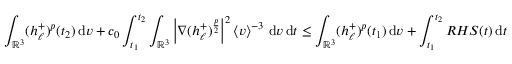Convert formula to latex. <formula><loc_0><loc_0><loc_500><loc_500>\int _ { { \mathbb { R } } ^ { 3 } } ( h _ { \ell } ^ { + } ) ^ { p } ( t _ { 2 } ) \, d v + c _ { 0 } \int _ { t _ { 1 } } ^ { t _ { 2 } } \int _ { { \mathbb { R } } ^ { 3 } } \left | \nabla ( h _ { \ell } ^ { + } ) ^ { \frac { p } { 2 } } \right | ^ { 2 } \left \langle v \right \rangle ^ { - 3 } \, d v \, d t \leq \int _ { { \mathbb { R } } ^ { 3 } } ( h _ { \ell } ^ { + } ) ^ { p } ( t _ { 1 } ) \, d v + \int _ { t _ { 1 } } ^ { t _ { 2 } } R H S ( t ) \, d t</formula> 